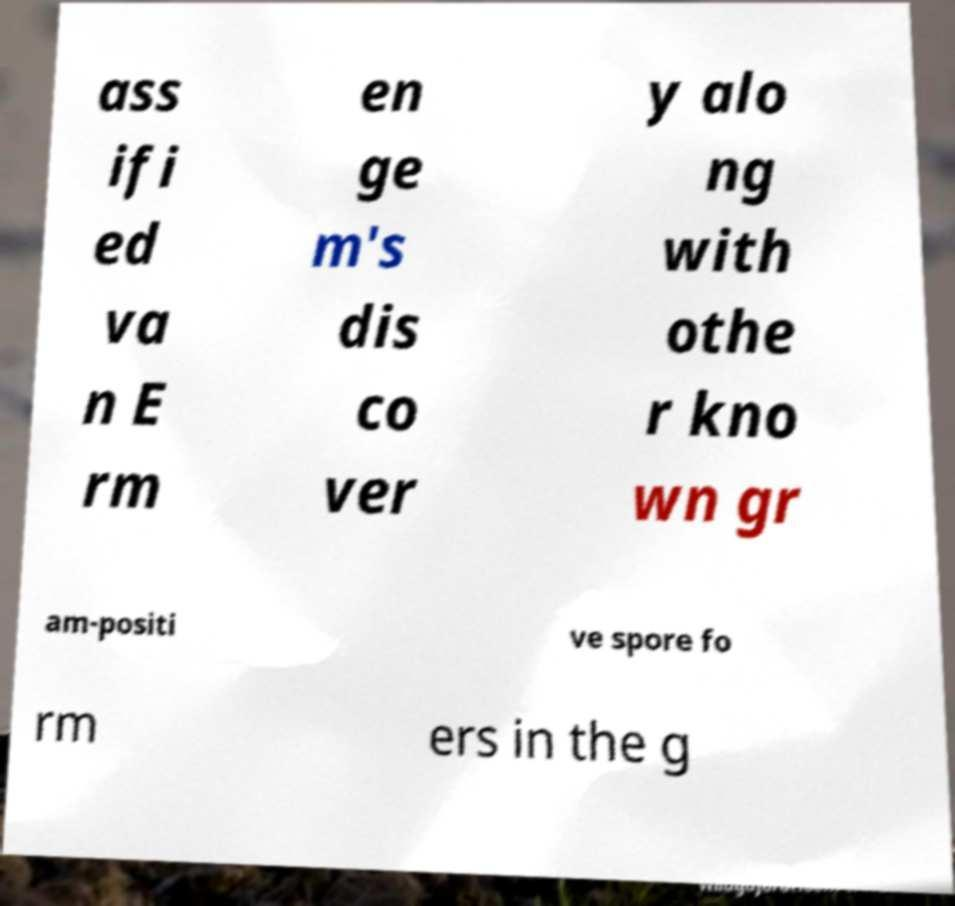Please read and relay the text visible in this image. What does it say? ass ifi ed va n E rm en ge m's dis co ver y alo ng with othe r kno wn gr am-positi ve spore fo rm ers in the g 